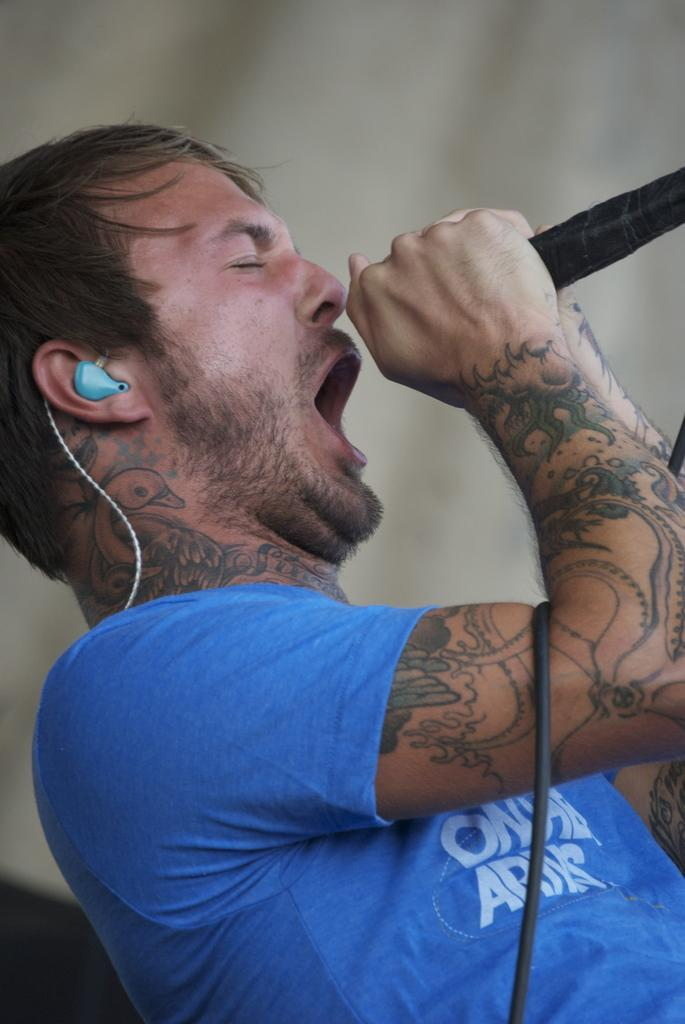What is the main subject of the image? There is a person in the image. What is the person wearing? The person is wearing a blue banyan. What object is the person holding? The person is holding a microphone. What type of accessory is the person wearing on their head? The person is wearing a headset. What type of yam is visible in the image? There is no yam present in the image. How does the snow affect the person's appearance in the image? There is no snow present in the image, so it does not affect the person's appearance. 